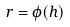Convert formula to latex. <formula><loc_0><loc_0><loc_500><loc_500>r = \phi ( h )</formula> 